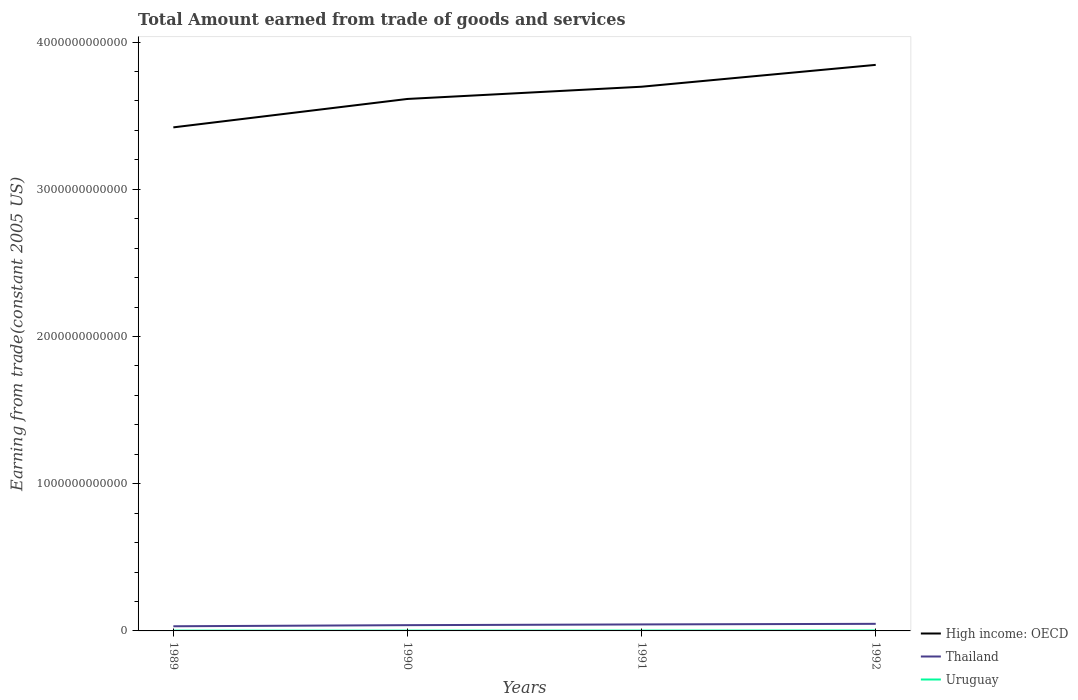Across all years, what is the maximum total amount earned by trading goods and services in Uruguay?
Keep it short and to the point. 1.97e+09. In which year was the total amount earned by trading goods and services in High income: OECD maximum?
Your answer should be very brief. 1989. What is the total total amount earned by trading goods and services in Uruguay in the graph?
Ensure brevity in your answer.  1.30e+07. What is the difference between the highest and the second highest total amount earned by trading goods and services in Thailand?
Your answer should be compact. 1.65e+1. What is the difference between two consecutive major ticks on the Y-axis?
Offer a very short reply. 1.00e+12. How many legend labels are there?
Your answer should be compact. 3. How are the legend labels stacked?
Give a very brief answer. Vertical. What is the title of the graph?
Keep it short and to the point. Total Amount earned from trade of goods and services. What is the label or title of the Y-axis?
Your answer should be very brief. Earning from trade(constant 2005 US). What is the Earning from trade(constant 2005 US) of High income: OECD in 1989?
Your response must be concise. 3.42e+12. What is the Earning from trade(constant 2005 US) in Thailand in 1989?
Provide a succinct answer. 3.16e+1. What is the Earning from trade(constant 2005 US) in Uruguay in 1989?
Ensure brevity in your answer.  1.98e+09. What is the Earning from trade(constant 2005 US) of High income: OECD in 1990?
Keep it short and to the point. 3.61e+12. What is the Earning from trade(constant 2005 US) in Thailand in 1990?
Offer a very short reply. 3.91e+1. What is the Earning from trade(constant 2005 US) of Uruguay in 1990?
Your answer should be compact. 1.97e+09. What is the Earning from trade(constant 2005 US) in High income: OECD in 1991?
Make the answer very short. 3.70e+12. What is the Earning from trade(constant 2005 US) of Thailand in 1991?
Make the answer very short. 4.42e+1. What is the Earning from trade(constant 2005 US) of Uruguay in 1991?
Provide a succinct answer. 2.32e+09. What is the Earning from trade(constant 2005 US) in High income: OECD in 1992?
Offer a terse response. 3.85e+12. What is the Earning from trade(constant 2005 US) of Thailand in 1992?
Your answer should be very brief. 4.82e+1. What is the Earning from trade(constant 2005 US) in Uruguay in 1992?
Offer a terse response. 2.91e+09. Across all years, what is the maximum Earning from trade(constant 2005 US) of High income: OECD?
Provide a short and direct response. 3.85e+12. Across all years, what is the maximum Earning from trade(constant 2005 US) of Thailand?
Your response must be concise. 4.82e+1. Across all years, what is the maximum Earning from trade(constant 2005 US) of Uruguay?
Your answer should be very brief. 2.91e+09. Across all years, what is the minimum Earning from trade(constant 2005 US) of High income: OECD?
Provide a short and direct response. 3.42e+12. Across all years, what is the minimum Earning from trade(constant 2005 US) of Thailand?
Offer a very short reply. 3.16e+1. Across all years, what is the minimum Earning from trade(constant 2005 US) in Uruguay?
Your answer should be very brief. 1.97e+09. What is the total Earning from trade(constant 2005 US) of High income: OECD in the graph?
Your answer should be compact. 1.46e+13. What is the total Earning from trade(constant 2005 US) in Thailand in the graph?
Make the answer very short. 1.63e+11. What is the total Earning from trade(constant 2005 US) in Uruguay in the graph?
Provide a short and direct response. 9.18e+09. What is the difference between the Earning from trade(constant 2005 US) of High income: OECD in 1989 and that in 1990?
Your answer should be compact. -1.93e+11. What is the difference between the Earning from trade(constant 2005 US) of Thailand in 1989 and that in 1990?
Offer a very short reply. -7.49e+09. What is the difference between the Earning from trade(constant 2005 US) in Uruguay in 1989 and that in 1990?
Provide a short and direct response. 1.30e+07. What is the difference between the Earning from trade(constant 2005 US) in High income: OECD in 1989 and that in 1991?
Make the answer very short. -2.76e+11. What is the difference between the Earning from trade(constant 2005 US) in Thailand in 1989 and that in 1991?
Ensure brevity in your answer.  -1.26e+1. What is the difference between the Earning from trade(constant 2005 US) of Uruguay in 1989 and that in 1991?
Your answer should be compact. -3.43e+08. What is the difference between the Earning from trade(constant 2005 US) of High income: OECD in 1989 and that in 1992?
Your response must be concise. -4.25e+11. What is the difference between the Earning from trade(constant 2005 US) of Thailand in 1989 and that in 1992?
Your answer should be compact. -1.65e+1. What is the difference between the Earning from trade(constant 2005 US) in Uruguay in 1989 and that in 1992?
Provide a short and direct response. -9.26e+08. What is the difference between the Earning from trade(constant 2005 US) of High income: OECD in 1990 and that in 1991?
Make the answer very short. -8.31e+1. What is the difference between the Earning from trade(constant 2005 US) of Thailand in 1990 and that in 1991?
Provide a succinct answer. -5.06e+09. What is the difference between the Earning from trade(constant 2005 US) of Uruguay in 1990 and that in 1991?
Your answer should be compact. -3.56e+08. What is the difference between the Earning from trade(constant 2005 US) in High income: OECD in 1990 and that in 1992?
Your answer should be compact. -2.32e+11. What is the difference between the Earning from trade(constant 2005 US) in Thailand in 1990 and that in 1992?
Your answer should be compact. -9.03e+09. What is the difference between the Earning from trade(constant 2005 US) in Uruguay in 1990 and that in 1992?
Keep it short and to the point. -9.39e+08. What is the difference between the Earning from trade(constant 2005 US) of High income: OECD in 1991 and that in 1992?
Provide a short and direct response. -1.48e+11. What is the difference between the Earning from trade(constant 2005 US) of Thailand in 1991 and that in 1992?
Keep it short and to the point. -3.96e+09. What is the difference between the Earning from trade(constant 2005 US) in Uruguay in 1991 and that in 1992?
Give a very brief answer. -5.84e+08. What is the difference between the Earning from trade(constant 2005 US) in High income: OECD in 1989 and the Earning from trade(constant 2005 US) in Thailand in 1990?
Offer a very short reply. 3.38e+12. What is the difference between the Earning from trade(constant 2005 US) of High income: OECD in 1989 and the Earning from trade(constant 2005 US) of Uruguay in 1990?
Offer a terse response. 3.42e+12. What is the difference between the Earning from trade(constant 2005 US) in Thailand in 1989 and the Earning from trade(constant 2005 US) in Uruguay in 1990?
Offer a very short reply. 2.97e+1. What is the difference between the Earning from trade(constant 2005 US) in High income: OECD in 1989 and the Earning from trade(constant 2005 US) in Thailand in 1991?
Your answer should be very brief. 3.38e+12. What is the difference between the Earning from trade(constant 2005 US) in High income: OECD in 1989 and the Earning from trade(constant 2005 US) in Uruguay in 1991?
Provide a succinct answer. 3.42e+12. What is the difference between the Earning from trade(constant 2005 US) in Thailand in 1989 and the Earning from trade(constant 2005 US) in Uruguay in 1991?
Ensure brevity in your answer.  2.93e+1. What is the difference between the Earning from trade(constant 2005 US) of High income: OECD in 1989 and the Earning from trade(constant 2005 US) of Thailand in 1992?
Make the answer very short. 3.37e+12. What is the difference between the Earning from trade(constant 2005 US) of High income: OECD in 1989 and the Earning from trade(constant 2005 US) of Uruguay in 1992?
Keep it short and to the point. 3.42e+12. What is the difference between the Earning from trade(constant 2005 US) in Thailand in 1989 and the Earning from trade(constant 2005 US) in Uruguay in 1992?
Your answer should be compact. 2.87e+1. What is the difference between the Earning from trade(constant 2005 US) in High income: OECD in 1990 and the Earning from trade(constant 2005 US) in Thailand in 1991?
Give a very brief answer. 3.57e+12. What is the difference between the Earning from trade(constant 2005 US) of High income: OECD in 1990 and the Earning from trade(constant 2005 US) of Uruguay in 1991?
Your answer should be compact. 3.61e+12. What is the difference between the Earning from trade(constant 2005 US) of Thailand in 1990 and the Earning from trade(constant 2005 US) of Uruguay in 1991?
Your response must be concise. 3.68e+1. What is the difference between the Earning from trade(constant 2005 US) of High income: OECD in 1990 and the Earning from trade(constant 2005 US) of Thailand in 1992?
Give a very brief answer. 3.57e+12. What is the difference between the Earning from trade(constant 2005 US) in High income: OECD in 1990 and the Earning from trade(constant 2005 US) in Uruguay in 1992?
Provide a succinct answer. 3.61e+12. What is the difference between the Earning from trade(constant 2005 US) of Thailand in 1990 and the Earning from trade(constant 2005 US) of Uruguay in 1992?
Your answer should be very brief. 3.62e+1. What is the difference between the Earning from trade(constant 2005 US) of High income: OECD in 1991 and the Earning from trade(constant 2005 US) of Thailand in 1992?
Your answer should be compact. 3.65e+12. What is the difference between the Earning from trade(constant 2005 US) of High income: OECD in 1991 and the Earning from trade(constant 2005 US) of Uruguay in 1992?
Keep it short and to the point. 3.69e+12. What is the difference between the Earning from trade(constant 2005 US) of Thailand in 1991 and the Earning from trade(constant 2005 US) of Uruguay in 1992?
Your response must be concise. 4.13e+1. What is the average Earning from trade(constant 2005 US) of High income: OECD per year?
Offer a terse response. 3.64e+12. What is the average Earning from trade(constant 2005 US) of Thailand per year?
Your answer should be compact. 4.08e+1. What is the average Earning from trade(constant 2005 US) of Uruguay per year?
Provide a succinct answer. 2.29e+09. In the year 1989, what is the difference between the Earning from trade(constant 2005 US) of High income: OECD and Earning from trade(constant 2005 US) of Thailand?
Your answer should be very brief. 3.39e+12. In the year 1989, what is the difference between the Earning from trade(constant 2005 US) of High income: OECD and Earning from trade(constant 2005 US) of Uruguay?
Offer a terse response. 3.42e+12. In the year 1989, what is the difference between the Earning from trade(constant 2005 US) in Thailand and Earning from trade(constant 2005 US) in Uruguay?
Keep it short and to the point. 2.97e+1. In the year 1990, what is the difference between the Earning from trade(constant 2005 US) of High income: OECD and Earning from trade(constant 2005 US) of Thailand?
Give a very brief answer. 3.57e+12. In the year 1990, what is the difference between the Earning from trade(constant 2005 US) in High income: OECD and Earning from trade(constant 2005 US) in Uruguay?
Give a very brief answer. 3.61e+12. In the year 1990, what is the difference between the Earning from trade(constant 2005 US) of Thailand and Earning from trade(constant 2005 US) of Uruguay?
Your answer should be very brief. 3.72e+1. In the year 1991, what is the difference between the Earning from trade(constant 2005 US) of High income: OECD and Earning from trade(constant 2005 US) of Thailand?
Provide a short and direct response. 3.65e+12. In the year 1991, what is the difference between the Earning from trade(constant 2005 US) of High income: OECD and Earning from trade(constant 2005 US) of Uruguay?
Your answer should be very brief. 3.69e+12. In the year 1991, what is the difference between the Earning from trade(constant 2005 US) in Thailand and Earning from trade(constant 2005 US) in Uruguay?
Offer a very short reply. 4.19e+1. In the year 1992, what is the difference between the Earning from trade(constant 2005 US) in High income: OECD and Earning from trade(constant 2005 US) in Thailand?
Your answer should be very brief. 3.80e+12. In the year 1992, what is the difference between the Earning from trade(constant 2005 US) of High income: OECD and Earning from trade(constant 2005 US) of Uruguay?
Your answer should be compact. 3.84e+12. In the year 1992, what is the difference between the Earning from trade(constant 2005 US) in Thailand and Earning from trade(constant 2005 US) in Uruguay?
Give a very brief answer. 4.53e+1. What is the ratio of the Earning from trade(constant 2005 US) in High income: OECD in 1989 to that in 1990?
Provide a short and direct response. 0.95. What is the ratio of the Earning from trade(constant 2005 US) of Thailand in 1989 to that in 1990?
Offer a terse response. 0.81. What is the ratio of the Earning from trade(constant 2005 US) of Uruguay in 1989 to that in 1990?
Provide a succinct answer. 1.01. What is the ratio of the Earning from trade(constant 2005 US) of High income: OECD in 1989 to that in 1991?
Make the answer very short. 0.93. What is the ratio of the Earning from trade(constant 2005 US) of Thailand in 1989 to that in 1991?
Your answer should be compact. 0.72. What is the ratio of the Earning from trade(constant 2005 US) of Uruguay in 1989 to that in 1991?
Make the answer very short. 0.85. What is the ratio of the Earning from trade(constant 2005 US) of High income: OECD in 1989 to that in 1992?
Your answer should be compact. 0.89. What is the ratio of the Earning from trade(constant 2005 US) of Thailand in 1989 to that in 1992?
Provide a succinct answer. 0.66. What is the ratio of the Earning from trade(constant 2005 US) in Uruguay in 1989 to that in 1992?
Your answer should be very brief. 0.68. What is the ratio of the Earning from trade(constant 2005 US) in High income: OECD in 1990 to that in 1991?
Offer a terse response. 0.98. What is the ratio of the Earning from trade(constant 2005 US) of Thailand in 1990 to that in 1991?
Offer a terse response. 0.89. What is the ratio of the Earning from trade(constant 2005 US) in Uruguay in 1990 to that in 1991?
Offer a terse response. 0.85. What is the ratio of the Earning from trade(constant 2005 US) of High income: OECD in 1990 to that in 1992?
Offer a terse response. 0.94. What is the ratio of the Earning from trade(constant 2005 US) of Thailand in 1990 to that in 1992?
Make the answer very short. 0.81. What is the ratio of the Earning from trade(constant 2005 US) in Uruguay in 1990 to that in 1992?
Give a very brief answer. 0.68. What is the ratio of the Earning from trade(constant 2005 US) in High income: OECD in 1991 to that in 1992?
Your answer should be compact. 0.96. What is the ratio of the Earning from trade(constant 2005 US) in Thailand in 1991 to that in 1992?
Provide a succinct answer. 0.92. What is the ratio of the Earning from trade(constant 2005 US) in Uruguay in 1991 to that in 1992?
Offer a terse response. 0.8. What is the difference between the highest and the second highest Earning from trade(constant 2005 US) in High income: OECD?
Ensure brevity in your answer.  1.48e+11. What is the difference between the highest and the second highest Earning from trade(constant 2005 US) of Thailand?
Offer a terse response. 3.96e+09. What is the difference between the highest and the second highest Earning from trade(constant 2005 US) in Uruguay?
Your response must be concise. 5.84e+08. What is the difference between the highest and the lowest Earning from trade(constant 2005 US) of High income: OECD?
Provide a succinct answer. 4.25e+11. What is the difference between the highest and the lowest Earning from trade(constant 2005 US) in Thailand?
Offer a very short reply. 1.65e+1. What is the difference between the highest and the lowest Earning from trade(constant 2005 US) of Uruguay?
Your answer should be very brief. 9.39e+08. 